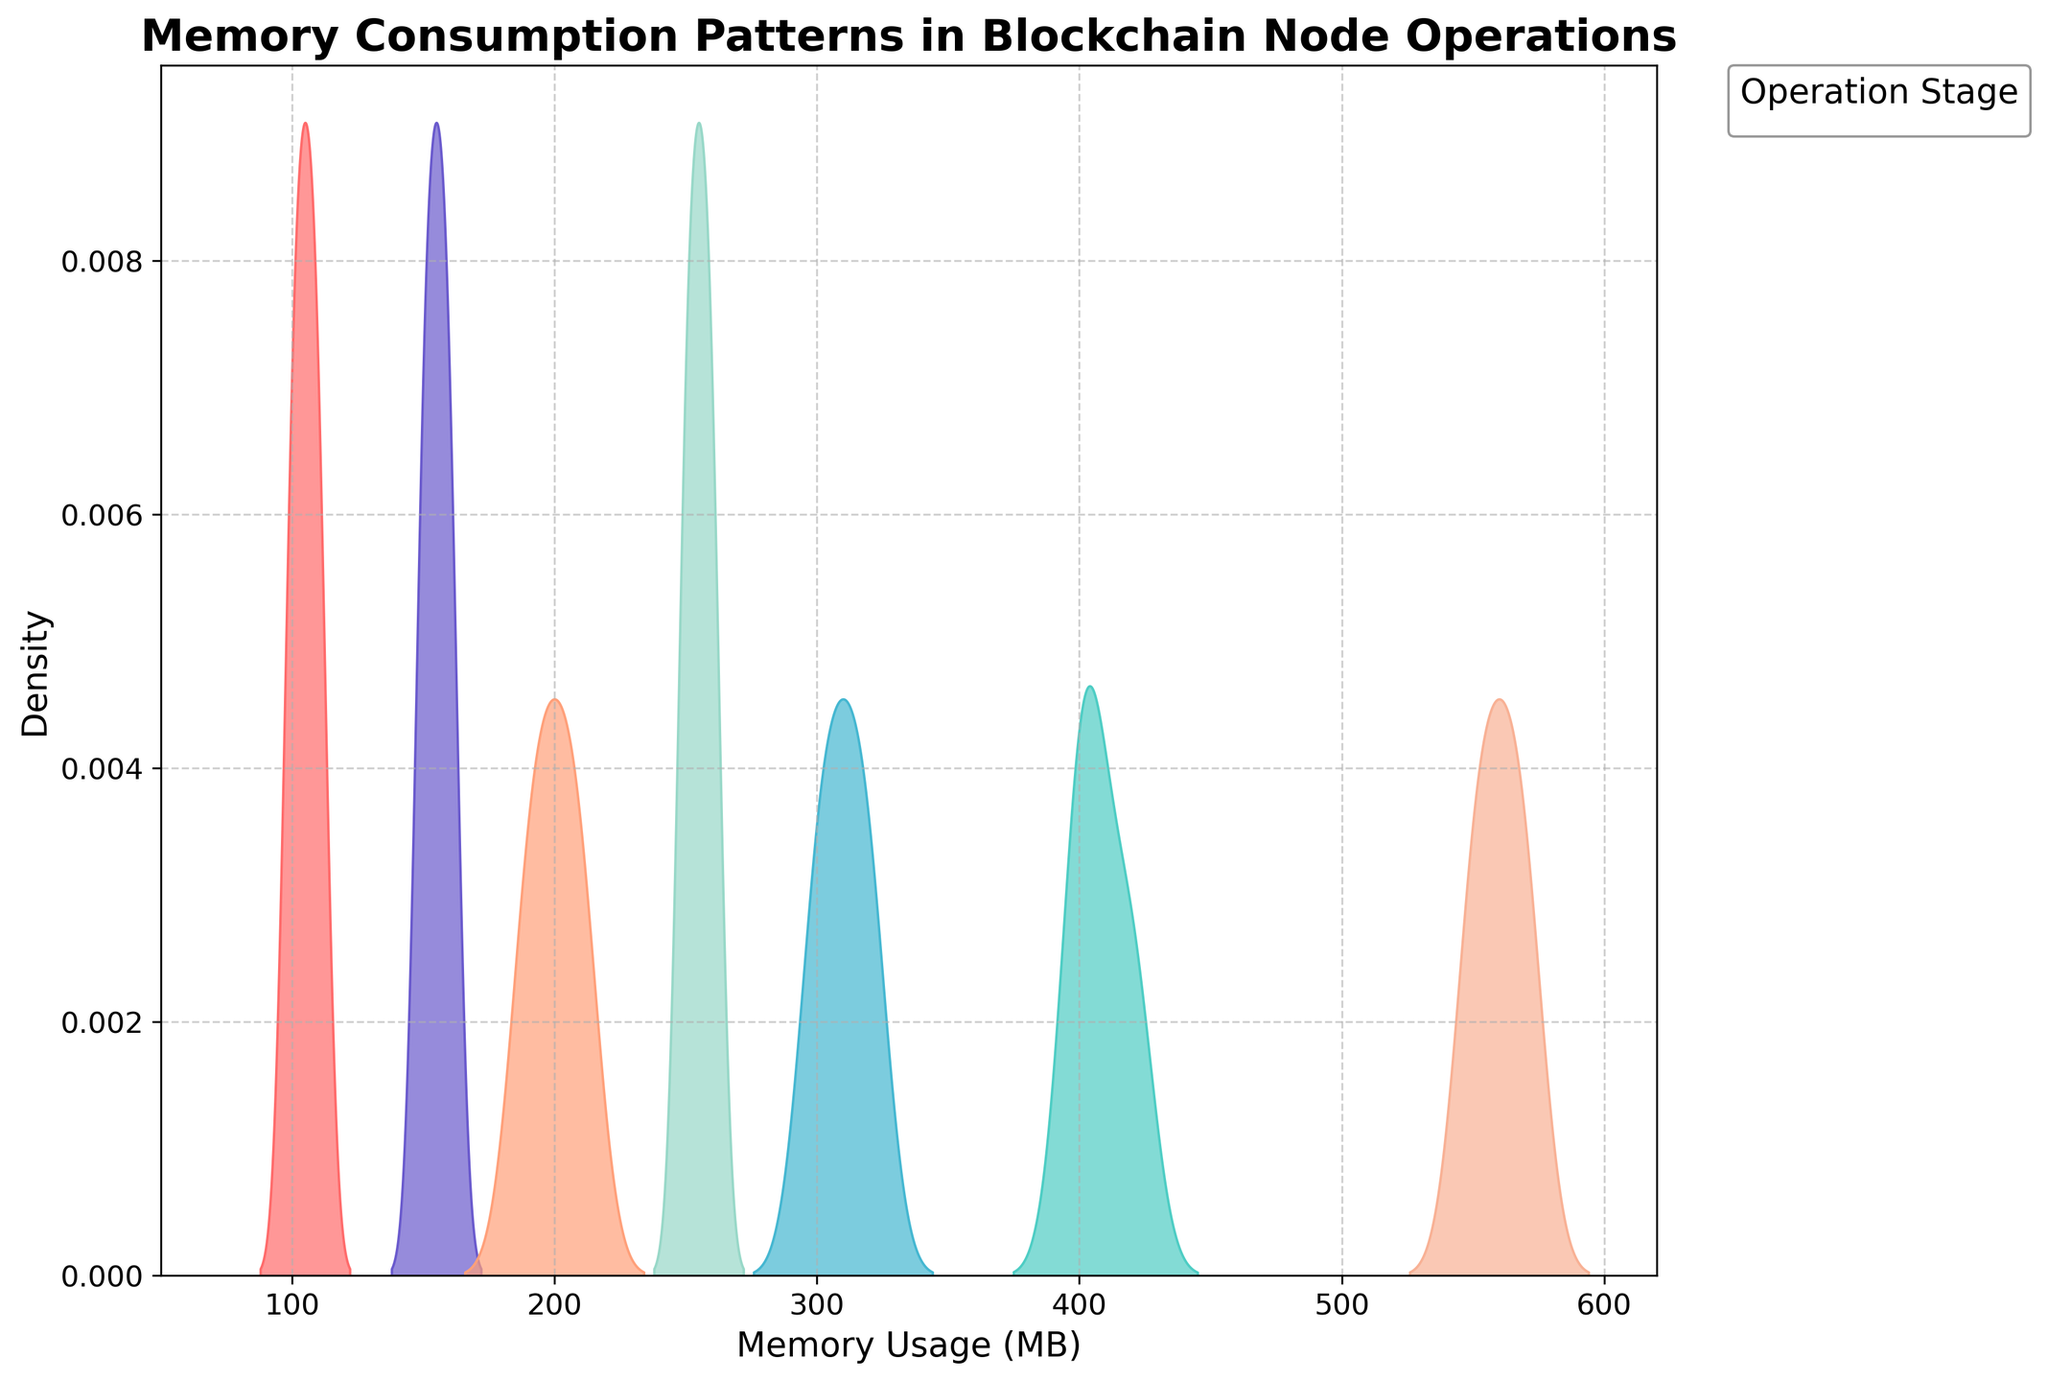what's the title of the plot? The title of the plot is displayed at the top and is a descriptive summary of what the graph represents. It indicates the subject matter of the plot.
Answer: Memory Consumption Patterns in Blockchain Node Operations what are the x and y axes labeled? The x and y axes labels provide information on what each axis represents. The x-axis shows the values of memory usage, while the y-axis shows the density.
Answer: The x-axis is labeled 'Memory Usage (MB)', and the y-axis is labeled 'Density' what memory range does the plot cover? To determine the memory range, observe the minimum and maximum memory usage values on the x-axis. The x-axis limits have been extended for better visualization.
Answer: 50 MB to 620 MB which stage has the highest peak in the density plot? To identify the stage with the highest peak, look for the curve that reaches the highest point on the y-axis. This represents the maximum density for that stage.
Answer: Syncing Blockchain which stages show memory usage below 200 MB? To find this, look at the density curves that touch or peak below the 200 MB mark on the x-axis. This means these stages operate within that memory usage range.
Answer: Node Start and Maintenance how does 'Node Start' memory usage compare to 'Transaction Processing'? Compare the density curves of the two stages by looking at their respective positions along the x-axis and their overlap with each other.
Answer: Node Start uses less memory than Transaction Processing what's the approximate memory usage range for 'Under Load'? Examine the 'Under Load' density curve and note the x-axis values it spans. This will give the memory usage range for this stage.
Answer: 500 MB to 600 MB which stage has the narrowest spread in memory usage? To determine this, look for the stage whose density curve is the narrowest and tallest. This represents less variation in memory usage for that stage.
Answer: Node Start how does 'Maintenance' memory usage range compare to 'Smart Contract Deployment'? Compare the spreads of the density curves for both stages along the x-axis to see the memory usage ranges.
Answer: Maintenance uses 150-160 MB, whereas Smart Contract Deployment uses 300-320 MB what can you infer about the memory consumption pattern during 'Consensus Mechanism'? Observe the 'Consensus Mechanism' density curve to see how memory usage is distributed, and note its position and shape on the x-axis. This helps infer stability and typical usage.
Answer: Consensus Mechanism has a stable and moderate memory usage around 250-260 MB 